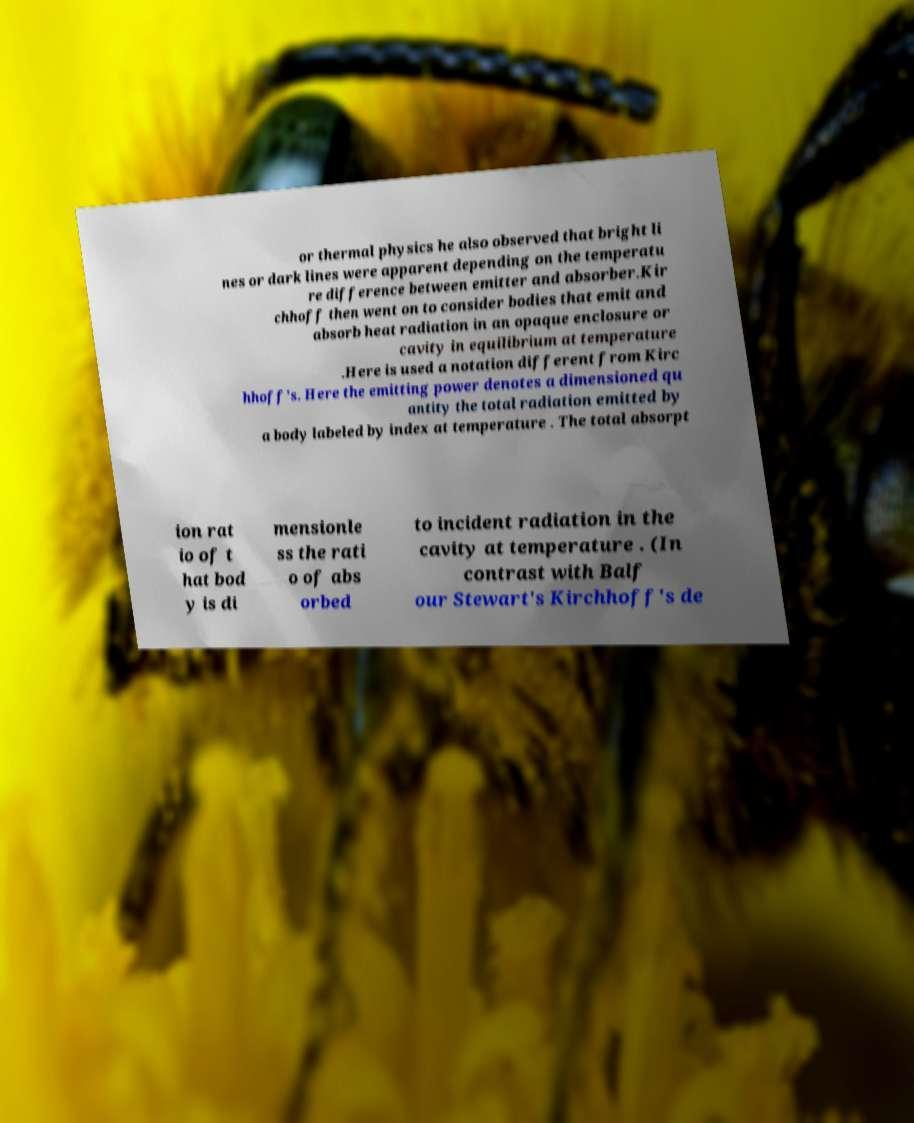Please read and relay the text visible in this image. What does it say? or thermal physics he also observed that bright li nes or dark lines were apparent depending on the temperatu re difference between emitter and absorber.Kir chhoff then went on to consider bodies that emit and absorb heat radiation in an opaque enclosure or cavity in equilibrium at temperature .Here is used a notation different from Kirc hhoff's. Here the emitting power denotes a dimensioned qu antity the total radiation emitted by a body labeled by index at temperature . The total absorpt ion rat io of t hat bod y is di mensionle ss the rati o of abs orbed to incident radiation in the cavity at temperature . (In contrast with Balf our Stewart's Kirchhoff's de 